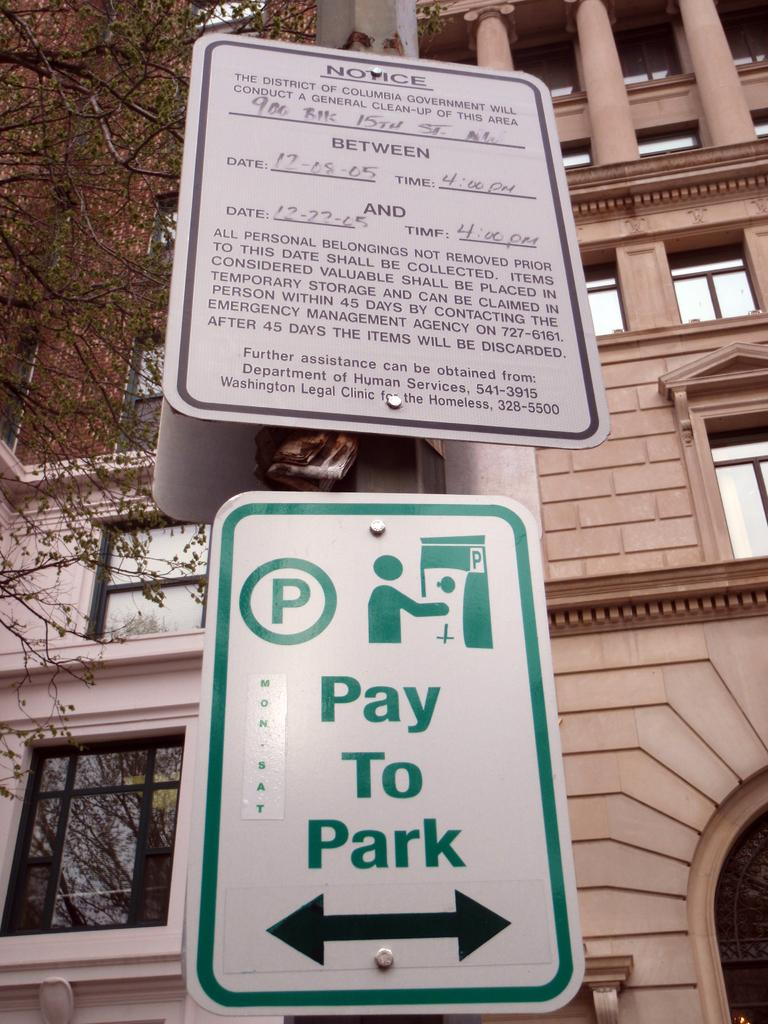<image>
Share a concise interpretation of the image provided. A green and white Pay to Park sign under a Notice sign. 